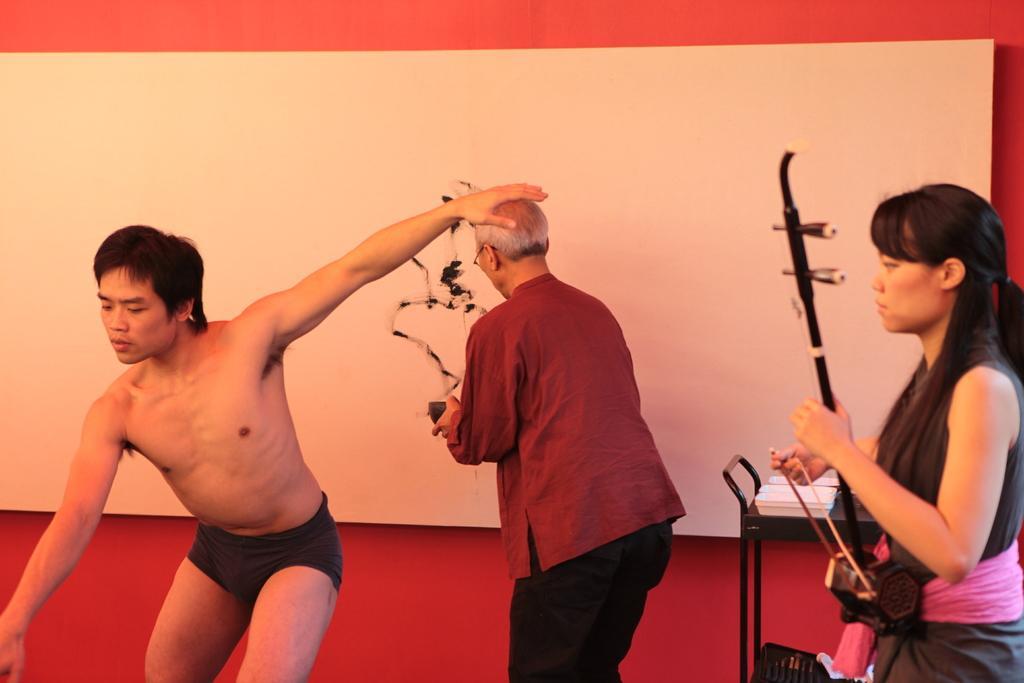Could you give a brief overview of what you see in this image? The picture consists of a woman and a man and an old man. On the right there is a desk, on the desk there are plates. In the background it is well. 